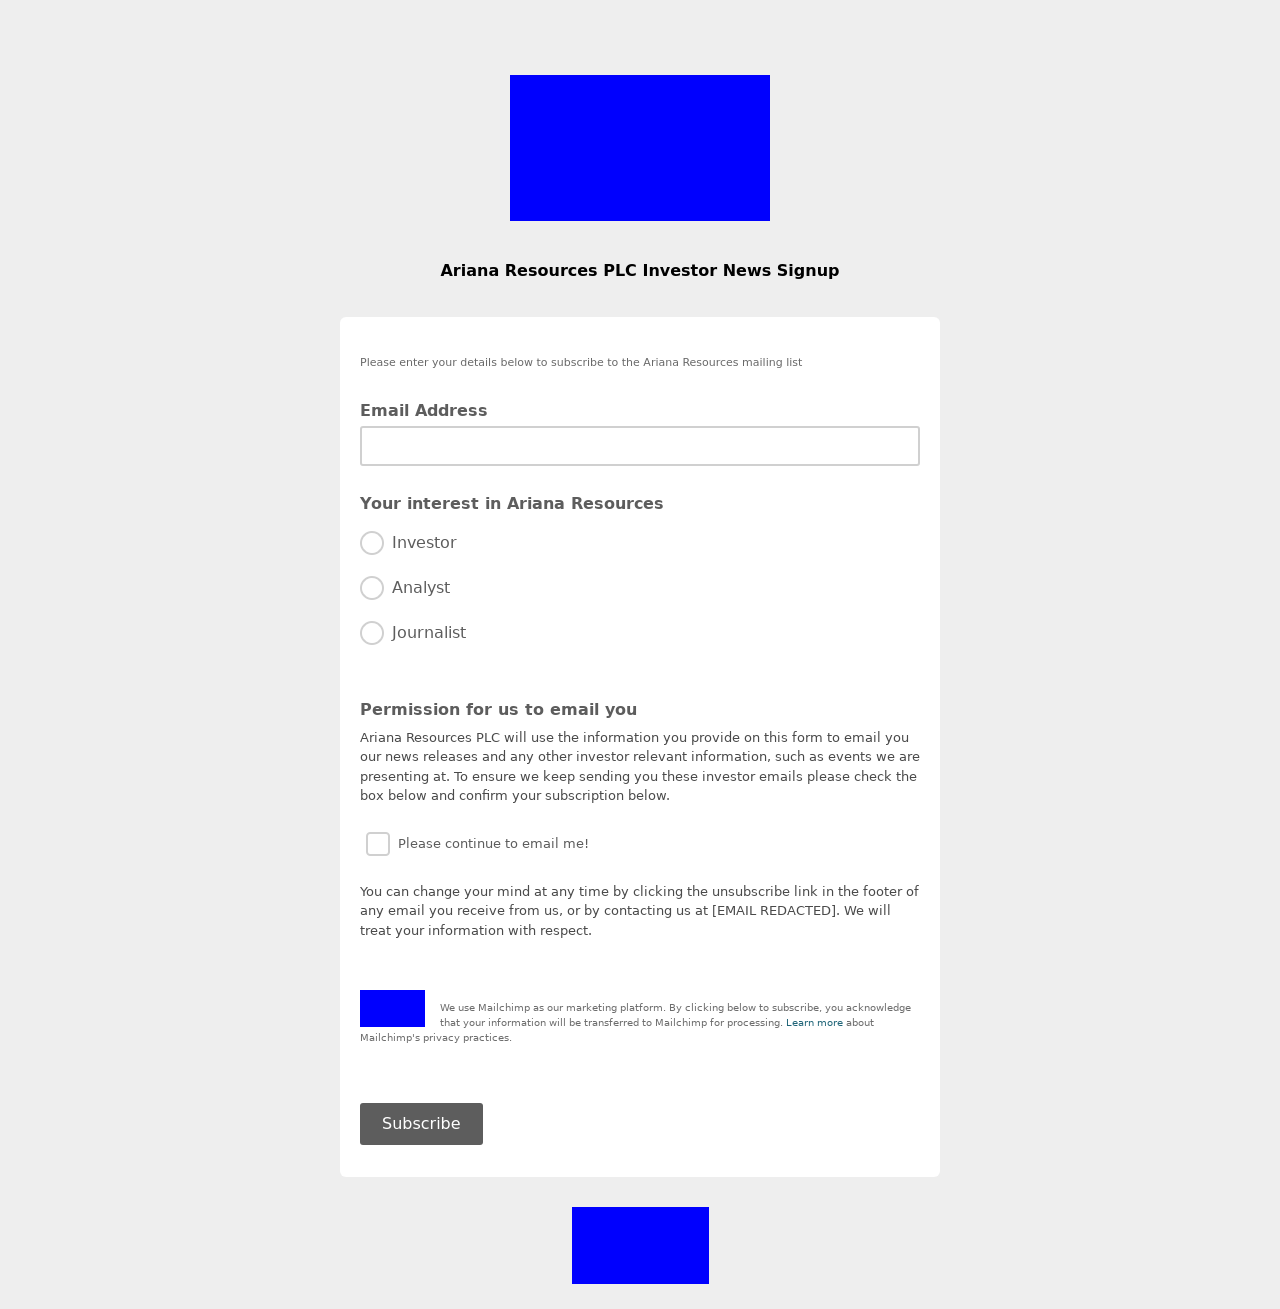Could you guide me through the process of developing this website with HTML? Absolutely! Developing a website with HTML involves several key steps:
1. **Structure**: Begin by defining the structure of your website using HTML tags. For instance, use '<!DOCTYPE html>' at the beginning to specify the document type and HTML version. Enclose everything in '<html>' tags.
2. **Head Section**: Inside the '<head>' tag, you can include your metadata, CSS styles, and other resources. Titles and character encoding settings go here too.
3. **Body Section**: The '<body>' tag will contain all contents visible to visitors, like paragraphs, images, links, and more.
4. **Content and Styling**: Fill the body with content using tags like '<div>', '<p>', and '<img>'. Use CSS within '<style>' tags in the head section or link to an external stylesheet to make your site visually appealing.
5. **Forms and Input**: The provided image shows parts of a form. Use '<form>' tags to capture user input. For emails, '<input type='email'>' is crucial for forming a newsletter signup page, as seen in the image.

By following these steps and continuously testing your webpage by reloading it in a browser, you can develop a functional and attractive website. 